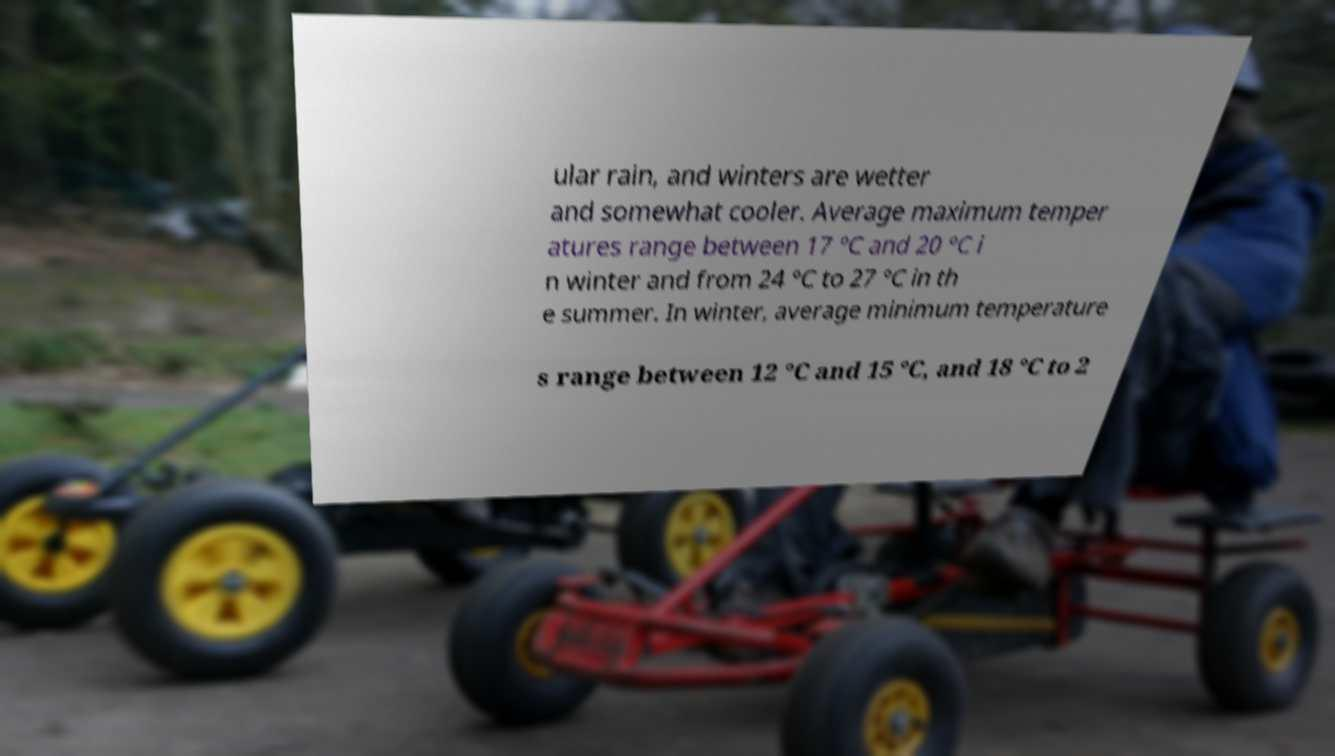Can you read and provide the text displayed in the image?This photo seems to have some interesting text. Can you extract and type it out for me? ular rain, and winters are wetter and somewhat cooler. Average maximum temper atures range between 17 °C and 20 °C i n winter and from 24 °C to 27 °C in th e summer. In winter, average minimum temperature s range between 12 °C and 15 °C, and 18 °C to 2 